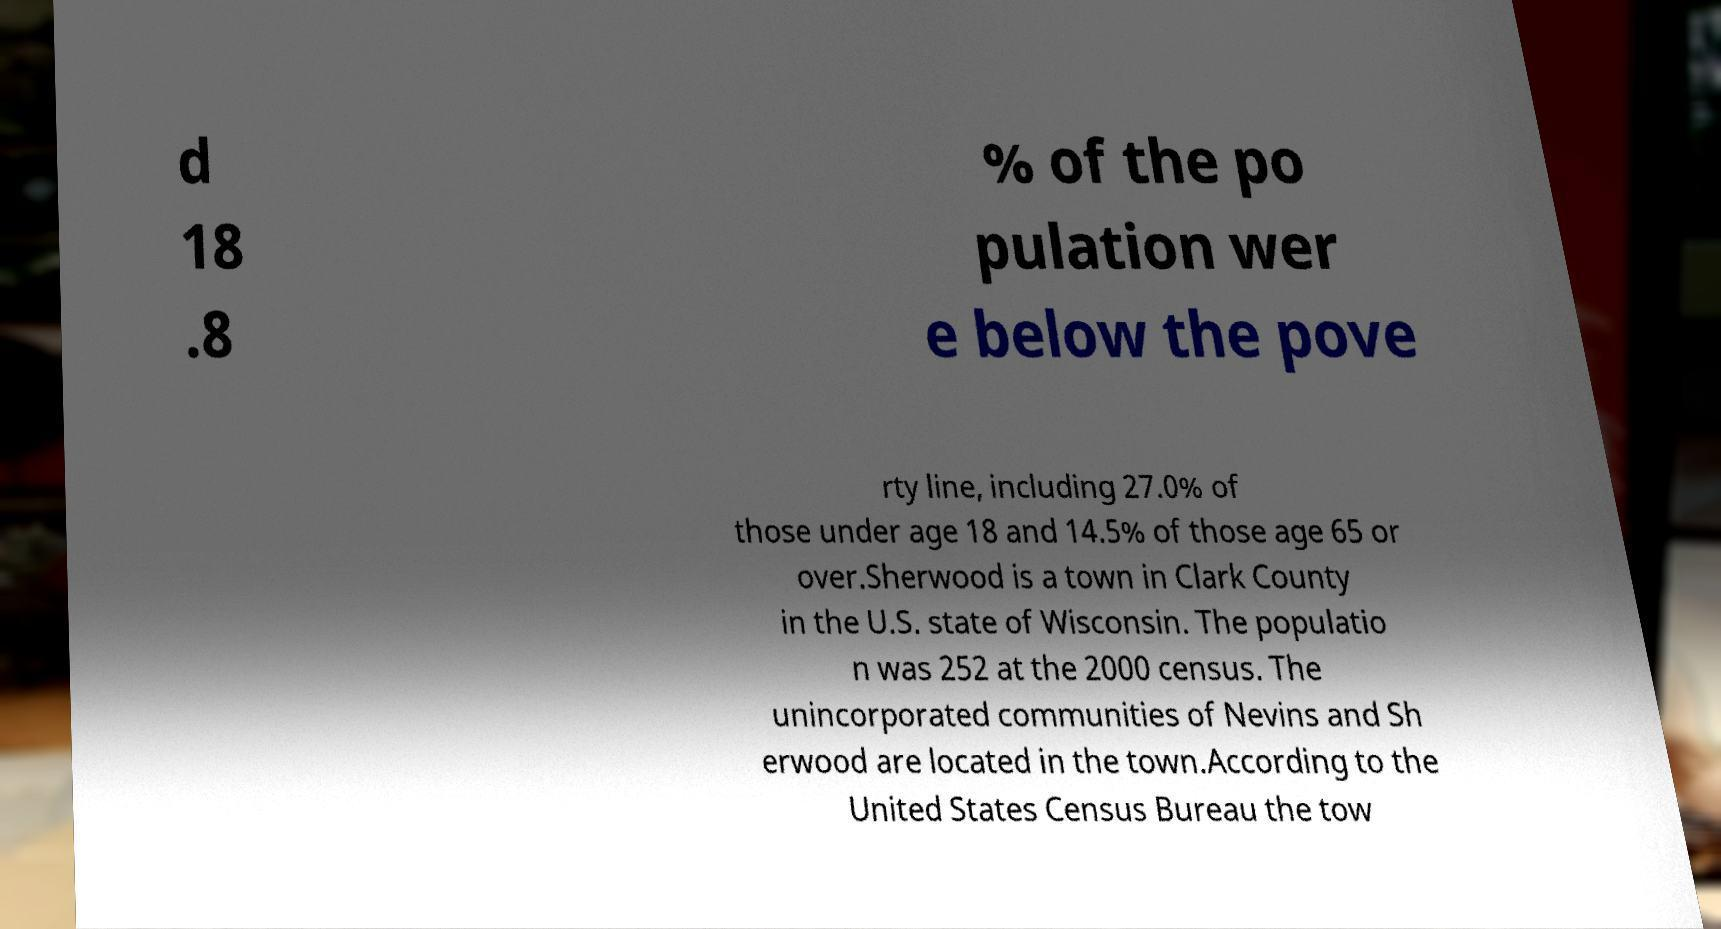I need the written content from this picture converted into text. Can you do that? d 18 .8 % of the po pulation wer e below the pove rty line, including 27.0% of those under age 18 and 14.5% of those age 65 or over.Sherwood is a town in Clark County in the U.S. state of Wisconsin. The populatio n was 252 at the 2000 census. The unincorporated communities of Nevins and Sh erwood are located in the town.According to the United States Census Bureau the tow 